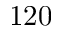<formula> <loc_0><loc_0><loc_500><loc_500>1 2 0</formula> 